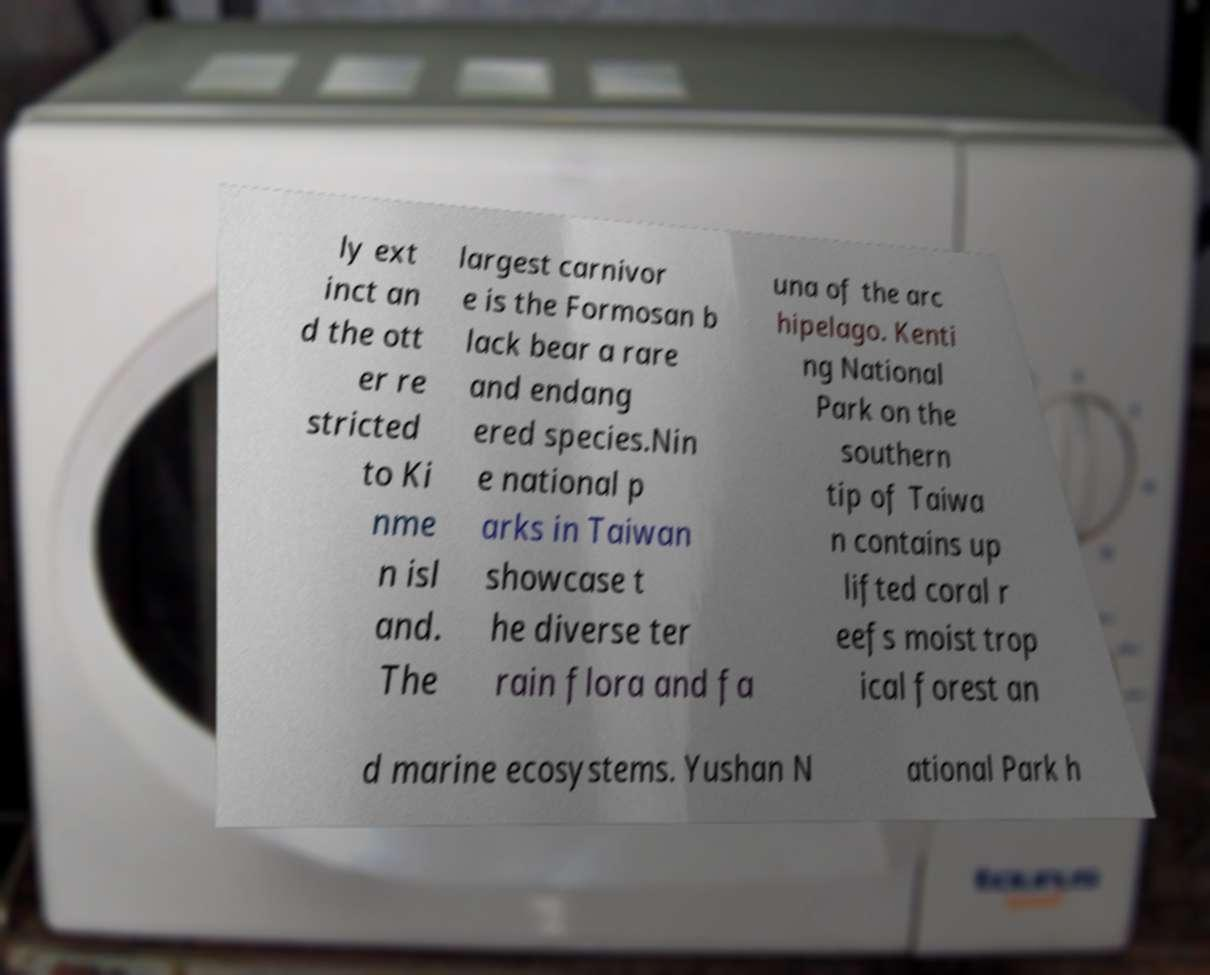Can you accurately transcribe the text from the provided image for me? ly ext inct an d the ott er re stricted to Ki nme n isl and. The largest carnivor e is the Formosan b lack bear a rare and endang ered species.Nin e national p arks in Taiwan showcase t he diverse ter rain flora and fa una of the arc hipelago. Kenti ng National Park on the southern tip of Taiwa n contains up lifted coral r eefs moist trop ical forest an d marine ecosystems. Yushan N ational Park h 